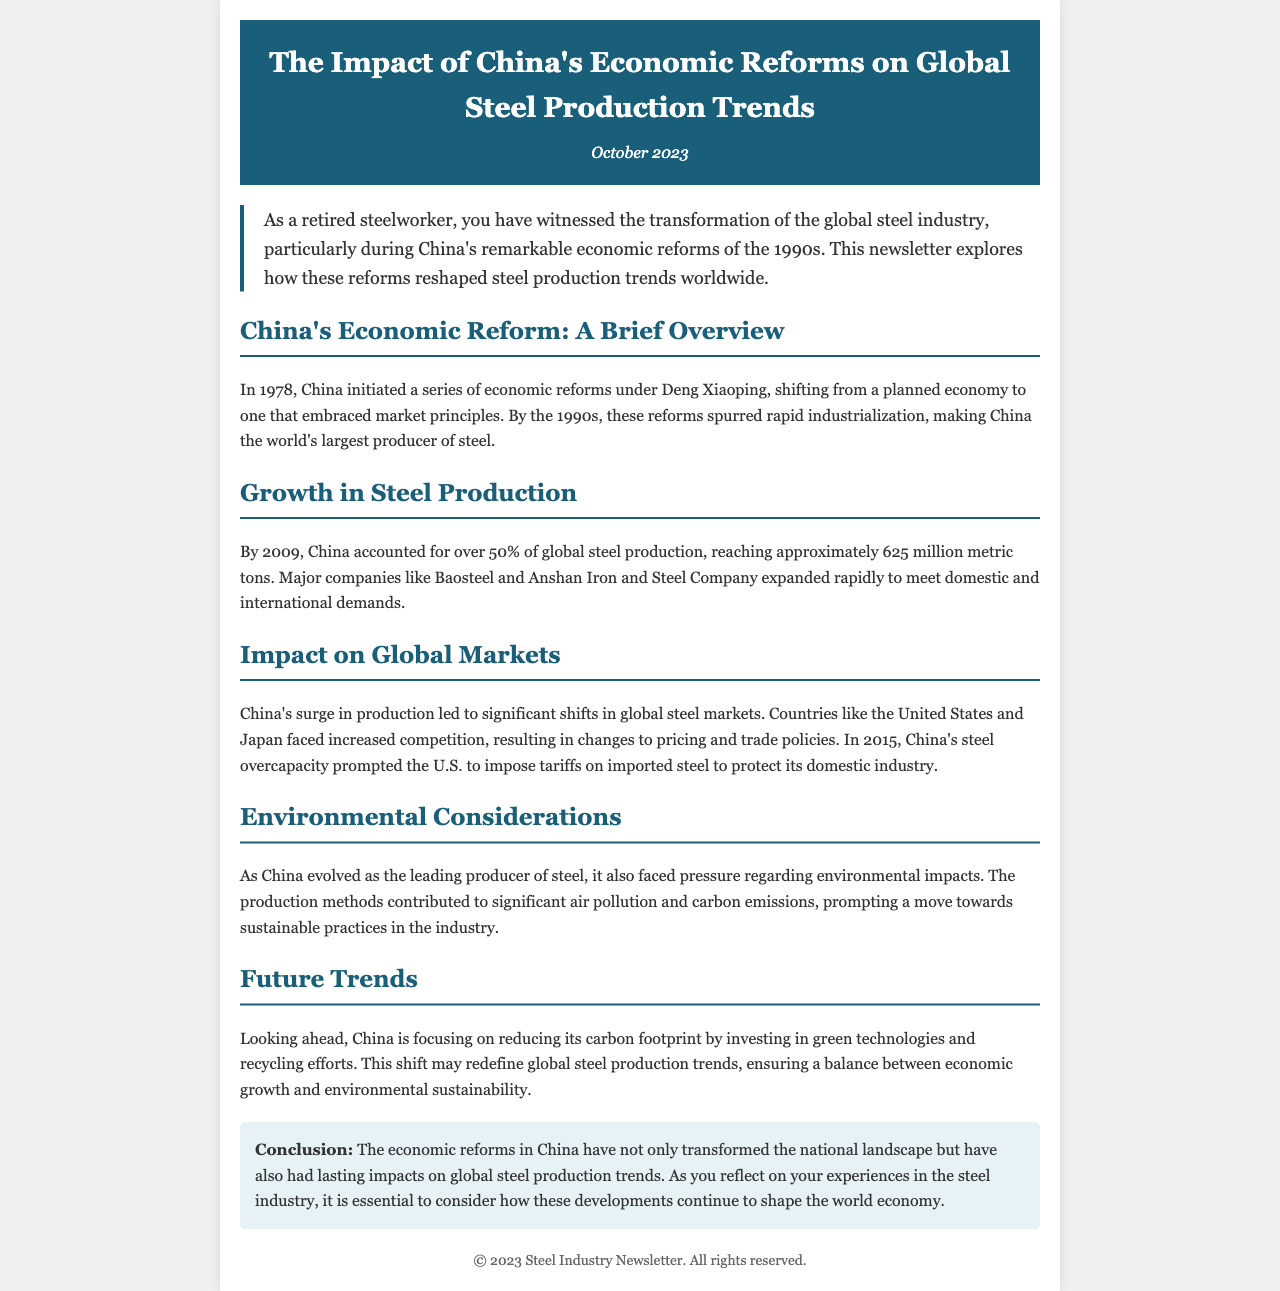What year did China initiate economic reforms? The document states that China initiated economic reforms in 1978.
Answer: 1978 What percentage of global steel production did China account for by 2009? By 2009, China accounted for over 50% of global steel production according to the document.
Answer: Over 50% Which major companies expanded rapidly due to China's steel production? The document mentions Baosteel and Anshan Iron and Steel Company as major companies that expanded.
Answer: Baosteel, Anshan Iron and Steel Company What did the U.S. impose on imported steel in 2015? The document mentions that the U.S. imposed tariffs on imported steel in 2015.
Answer: Tariffs What is China focusing on to reduce its carbon footprint? The document states that China is investing in green technologies and recycling efforts.
Answer: Green technologies and recycling efforts How has China's steel production affected global markets? The document explains that China's surge led to significant shifts in global steel markets and increased competition.
Answer: Increased competition What is a major environmental issue related to China’s steel production? The document notes that production methods contributed to significant air pollution and carbon emissions.
Answer: Air pollution and carbon emissions What is the main conclusion of the newsletter? The conclusion states that the economic reforms in China have transformed the national landscape and impacted global steel production trends.
Answer: Transformed the national landscape and impacted global steel production trends 